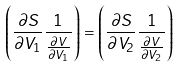Convert formula to latex. <formula><loc_0><loc_0><loc_500><loc_500>\left ( \frac { \partial S } { \partial V _ { 1 } } \frac { 1 } { \frac { \partial V } { \partial V _ { 1 } } } \right ) = \left ( \frac { \partial S } { \partial V _ { 2 } } \frac { 1 } { \frac { \partial V } { \partial V _ { 2 } } } \right )</formula> 